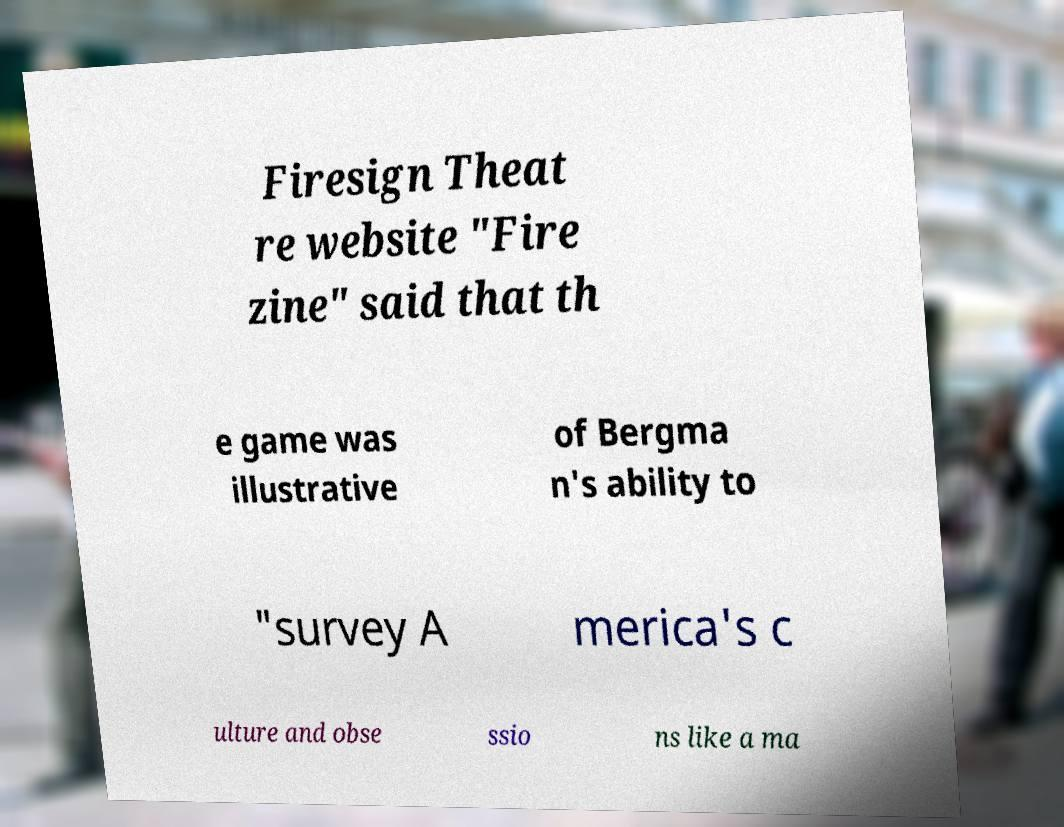Could you extract and type out the text from this image? Firesign Theat re website "Fire zine" said that th e game was illustrative of Bergma n's ability to "survey A merica's c ulture and obse ssio ns like a ma 